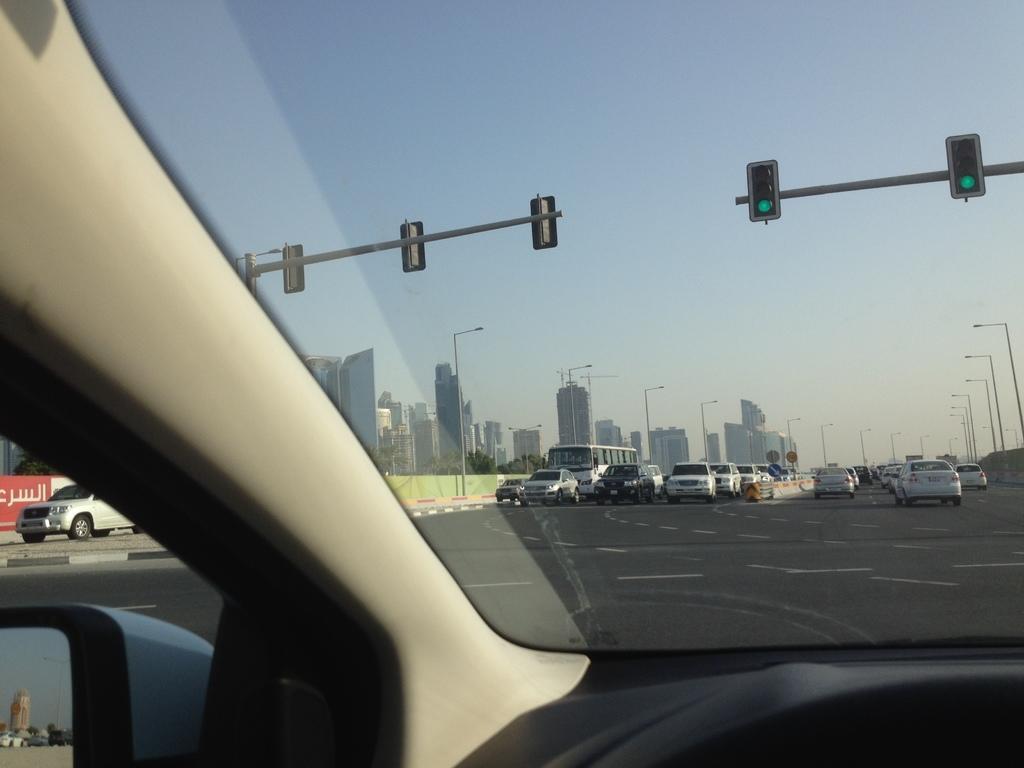Could you give a brief overview of what you see in this image? In this image in the center there are cars moving on the road and there are buildings there are light poles on the left side there is a car which is white in colour on the road and there is a banner with some text written on it. 